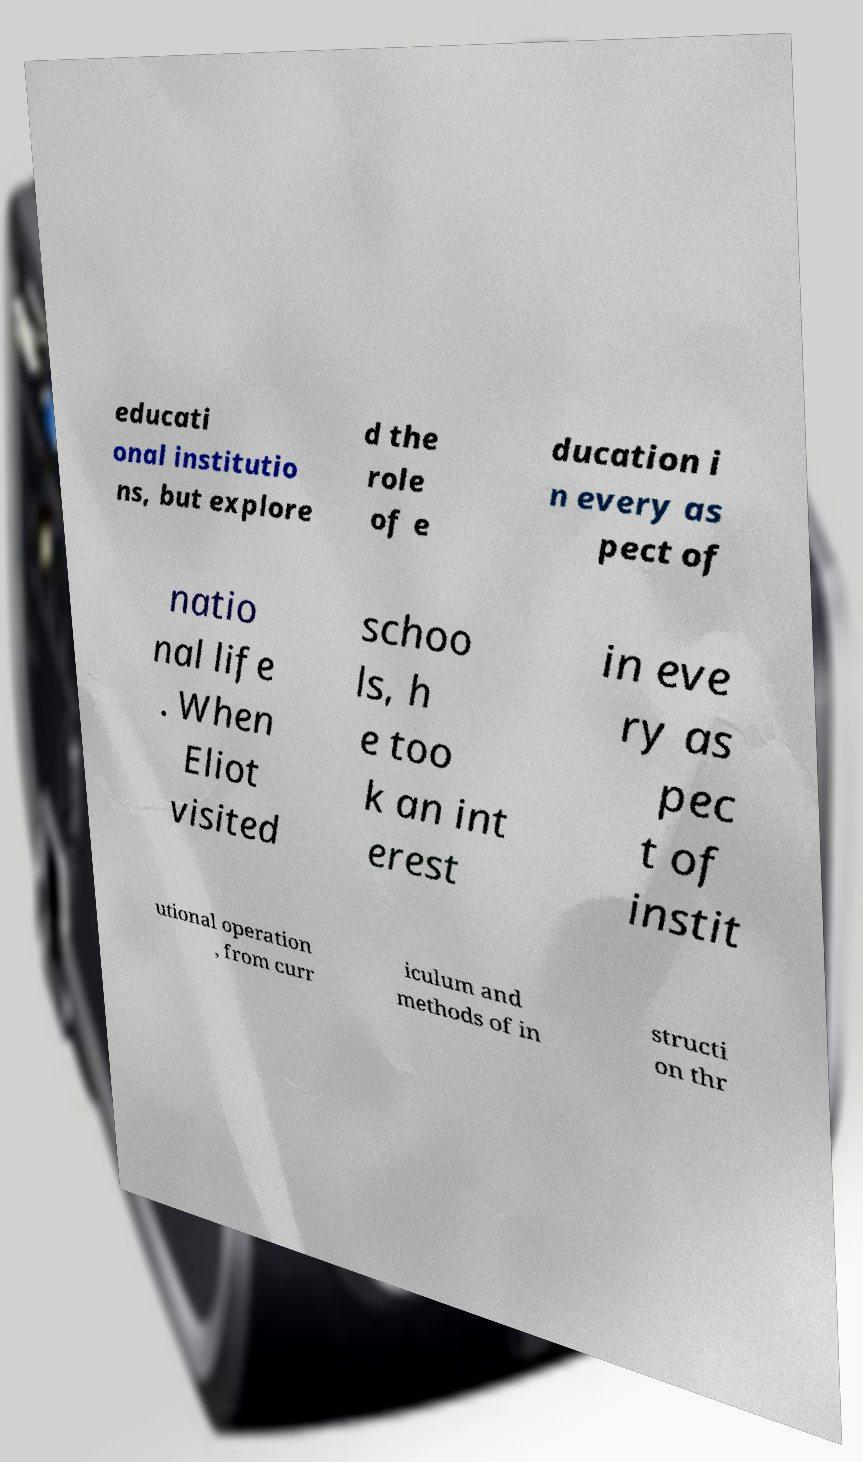Can you read and provide the text displayed in the image?This photo seems to have some interesting text. Can you extract and type it out for me? educati onal institutio ns, but explore d the role of e ducation i n every as pect of natio nal life . When Eliot visited schoo ls, h e too k an int erest in eve ry as pec t of instit utional operation , from curr iculum and methods of in structi on thr 